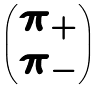<formula> <loc_0><loc_0><loc_500><loc_500>\begin{pmatrix} \pi _ { + } \\ \pi _ { - } \end{pmatrix}</formula> 